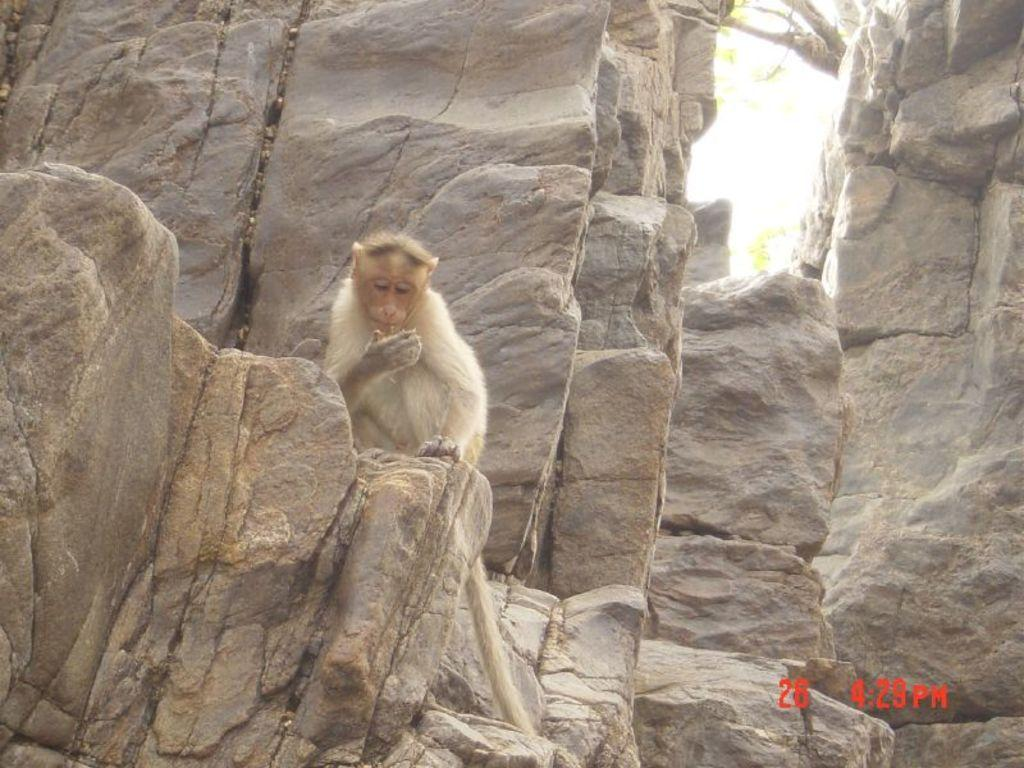What animal is present in the image? There is a monkey in the image. What is the monkey sitting on? The monkey is sitting on stones. Where can we find text in the image? There is red color text on the right side of the image. How many balls is the bear holding in the image? There is no bear or balls present in the image; it features a monkey sitting on stones. What type of fruit is the pear eating in the image? There is no pear or fruit-eating activity depicted in the image. 